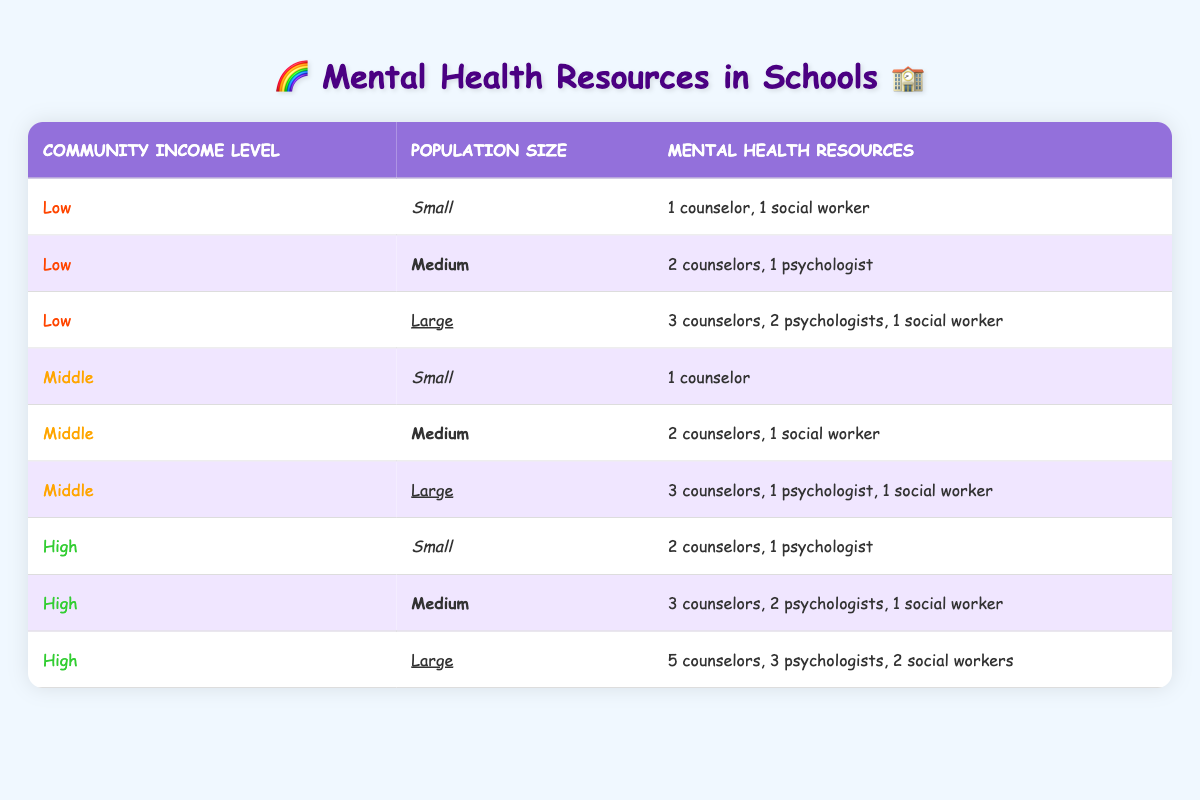What mental health resources are available in low-income communities with a medium population size? In the table, the row corresponding to "Low" community income level and "Medium" population size lists the mental health resources as "2 counselors, 1 psychologist."
Answer: 2 counselors, 1 psychologist True or False: High-income communities have more counselors than middle-income communities in large population sizes. For large population sizes, the high-income community has 5 counselors while the middle-income community has 3 counselors. Therefore, the statement is true.
Answer: True How many total mental health professionals (counselors, psychologists, and social workers) are available in high-income communities with large population sizes? In the row for high-income and large population size, the resources are listed as "5 counselors, 3 psychologists, 2 social workers." Adding them gives: 5 + 3 + 2 = 10 professionals.
Answer: 10 Which community income level has the fewest mental health resources available for small population sizes? The table shows that for small population sizes, low-income communities have "1 counselor, 1 social worker," while middle and high-income communities provide "1 counselor" and "2 counselors, 1 psychologist," respectively. So, the low-income community has the fewest with 2 total resources.
Answer: Low How does the number of mental health resources in middle-income communities compare to low-income communities in small population sizes? In small population sizes, low-income communities have "1 counselor, 1 social worker" (2 total resources), while middle-income communities only have "1 counselor" (1 total resource). Thus, low-income communities have more resources than middle-income communities for small populations.
Answer: Low-income communities have more resources How many mental health resources are available in total for low-income communities across all population sizes? For low-income communities, the totals are: small (2 resources), medium (3 resources), and large (6 resources). Adding them gives: 2 + 3 + 6 = 11 total resources.
Answer: 11 Is there a pattern in the availability of mental health resources as community income levels increase? Observing the table, as community income level increases from low to high, the resources also increase consistently across all population sizes, indicating a clear pattern of more resources with higher income levels.
Answer: Yes, there is a pattern What is the average number of counselors in middle-income communities regardless of population size? The middle-income community has counselors listed as: 1 (small), 2 (medium), and 3 (large). To find the average: (1 + 2 + 3) / 3 = 6 / 3 = 2 counselors on average.
Answer: 2 counselors 